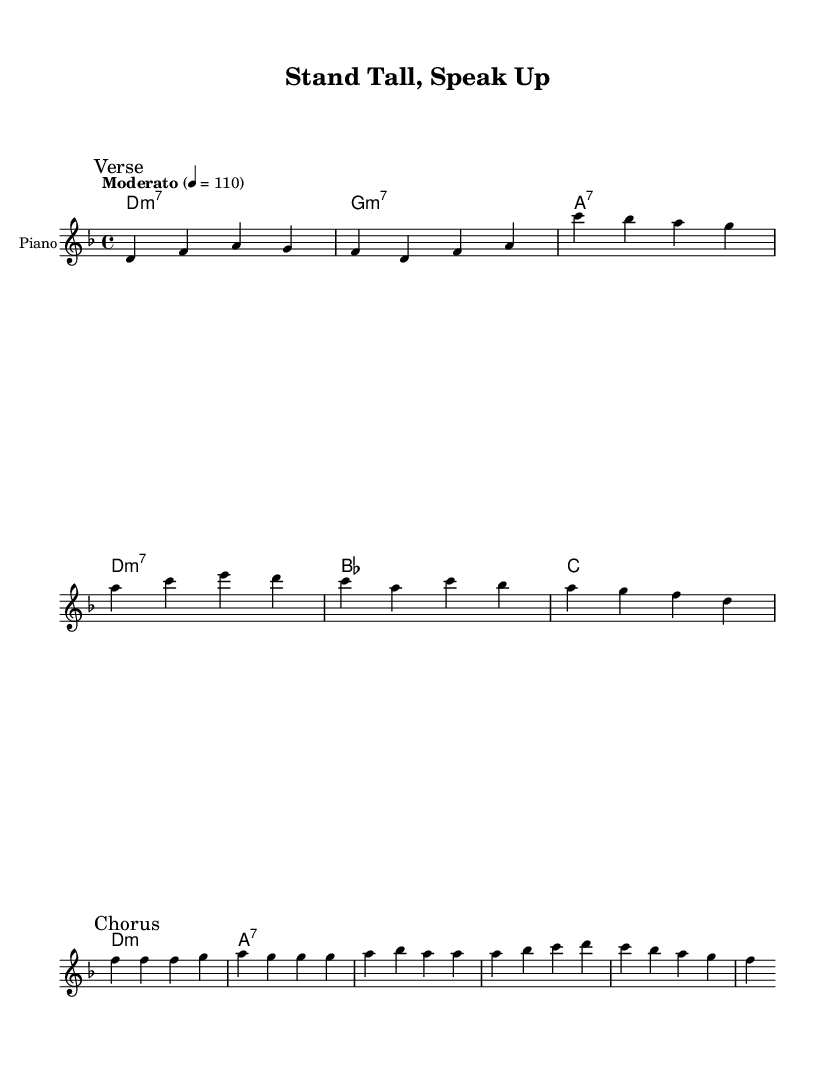What is the key signature of this music? The key signature shows two flats, which correspond to B♭ and E♭. This indicates the piece is in D minor, which has the same key signature as F major.
Answer: D minor What is the time signature of this piece? The time signature is indicated at the beginning of the score. It shows a "4/4" marking, meaning there are four beats in a measure and the quarter note gets one beat.
Answer: 4/4 What is the tempo marking for this piece? The tempo marking "Moderato" appears at the beginning of the score, and it is further described with a metronome marking of 110 beats per minute.
Answer: Moderato 110 How many measures are in the verse section? The verse section contains four measures, which can be counted from the first section marked "Verse" until the "Chorus" starts, spanning over the notes written.
Answer: Four What type of chords are used in the harmonies? Each chord in the harmony section follows the jazz chord structure indication, where you can identify minor seventh chords and dominant seventh chords. Examples include D minor 7 and A 7.
Answer: Minor and dominant seventh chords How does the melody in the chorus differ from the verse? The melody in the chorus is characterized by a more uplifting progression on the notes, as compared to the verses that have a more descending and reflective flow. This can be noticed through a comparison of the written notes.
Answer: Uplifting What is the overall theme of the lyrics? The lyrics convey a strong message of empowerment and standing up for one's rights and beliefs, encouraging assertiveness and confidence in challenging situations.
Answer: Empowerment 